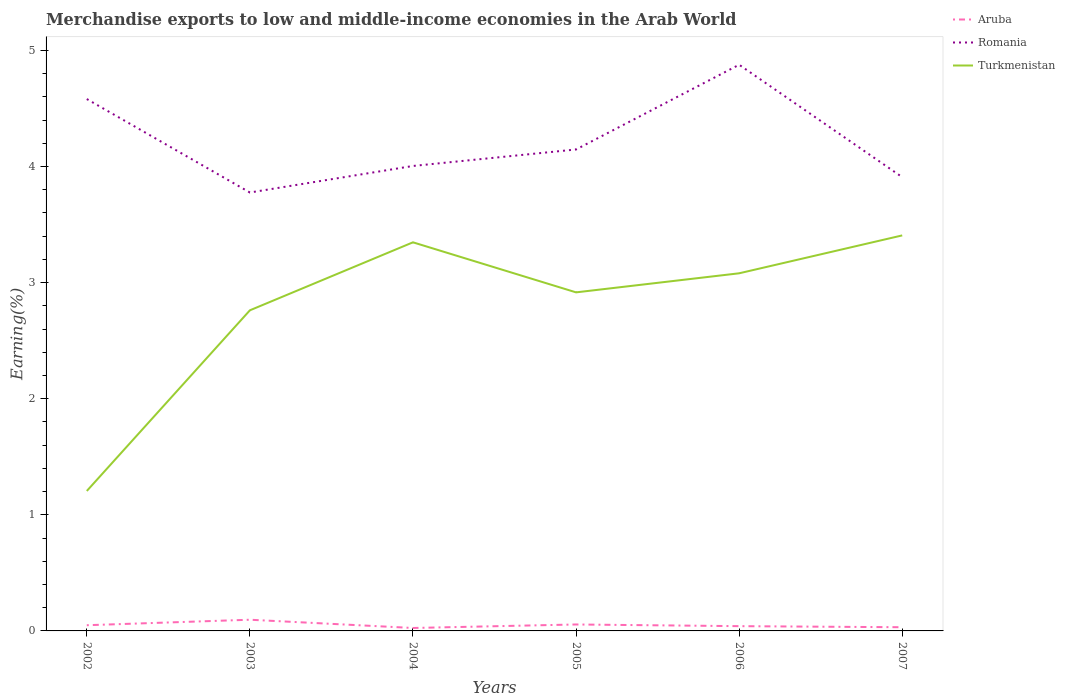How many different coloured lines are there?
Your answer should be very brief. 3. Across all years, what is the maximum percentage of amount earned from merchandise exports in Aruba?
Keep it short and to the point. 0.03. In which year was the percentage of amount earned from merchandise exports in Romania maximum?
Ensure brevity in your answer.  2003. What is the total percentage of amount earned from merchandise exports in Aruba in the graph?
Keep it short and to the point. 0.06. What is the difference between the highest and the second highest percentage of amount earned from merchandise exports in Turkmenistan?
Provide a short and direct response. 2.2. What is the difference between the highest and the lowest percentage of amount earned from merchandise exports in Romania?
Offer a terse response. 2. Is the percentage of amount earned from merchandise exports in Romania strictly greater than the percentage of amount earned from merchandise exports in Aruba over the years?
Make the answer very short. No. How many lines are there?
Provide a succinct answer. 3. Does the graph contain any zero values?
Offer a terse response. No. How many legend labels are there?
Offer a terse response. 3. What is the title of the graph?
Your answer should be compact. Merchandise exports to low and middle-income economies in the Arab World. Does "Caribbean small states" appear as one of the legend labels in the graph?
Offer a very short reply. No. What is the label or title of the X-axis?
Provide a short and direct response. Years. What is the label or title of the Y-axis?
Your response must be concise. Earning(%). What is the Earning(%) in Aruba in 2002?
Offer a very short reply. 0.05. What is the Earning(%) in Romania in 2002?
Your answer should be very brief. 4.58. What is the Earning(%) of Turkmenistan in 2002?
Offer a very short reply. 1.21. What is the Earning(%) in Aruba in 2003?
Your answer should be very brief. 0.1. What is the Earning(%) of Romania in 2003?
Give a very brief answer. 3.78. What is the Earning(%) of Turkmenistan in 2003?
Provide a succinct answer. 2.76. What is the Earning(%) in Aruba in 2004?
Your answer should be compact. 0.03. What is the Earning(%) in Romania in 2004?
Offer a terse response. 4. What is the Earning(%) of Turkmenistan in 2004?
Offer a terse response. 3.35. What is the Earning(%) in Aruba in 2005?
Your response must be concise. 0.06. What is the Earning(%) of Romania in 2005?
Provide a short and direct response. 4.15. What is the Earning(%) of Turkmenistan in 2005?
Your answer should be compact. 2.92. What is the Earning(%) of Aruba in 2006?
Ensure brevity in your answer.  0.04. What is the Earning(%) in Romania in 2006?
Your answer should be very brief. 4.88. What is the Earning(%) of Turkmenistan in 2006?
Provide a short and direct response. 3.08. What is the Earning(%) in Aruba in 2007?
Provide a short and direct response. 0.03. What is the Earning(%) of Romania in 2007?
Provide a short and direct response. 3.91. What is the Earning(%) of Turkmenistan in 2007?
Ensure brevity in your answer.  3.41. Across all years, what is the maximum Earning(%) in Aruba?
Keep it short and to the point. 0.1. Across all years, what is the maximum Earning(%) in Romania?
Give a very brief answer. 4.88. Across all years, what is the maximum Earning(%) in Turkmenistan?
Provide a succinct answer. 3.41. Across all years, what is the minimum Earning(%) in Aruba?
Give a very brief answer. 0.03. Across all years, what is the minimum Earning(%) of Romania?
Give a very brief answer. 3.78. Across all years, what is the minimum Earning(%) in Turkmenistan?
Ensure brevity in your answer.  1.21. What is the total Earning(%) of Aruba in the graph?
Provide a succinct answer. 0.3. What is the total Earning(%) in Romania in the graph?
Offer a very short reply. 25.29. What is the total Earning(%) in Turkmenistan in the graph?
Your answer should be compact. 16.71. What is the difference between the Earning(%) of Aruba in 2002 and that in 2003?
Ensure brevity in your answer.  -0.05. What is the difference between the Earning(%) in Romania in 2002 and that in 2003?
Offer a terse response. 0.8. What is the difference between the Earning(%) in Turkmenistan in 2002 and that in 2003?
Provide a succinct answer. -1.56. What is the difference between the Earning(%) in Aruba in 2002 and that in 2004?
Make the answer very short. 0.02. What is the difference between the Earning(%) in Romania in 2002 and that in 2004?
Your answer should be very brief. 0.58. What is the difference between the Earning(%) in Turkmenistan in 2002 and that in 2004?
Make the answer very short. -2.14. What is the difference between the Earning(%) of Aruba in 2002 and that in 2005?
Keep it short and to the point. -0.01. What is the difference between the Earning(%) of Romania in 2002 and that in 2005?
Offer a very short reply. 0.43. What is the difference between the Earning(%) in Turkmenistan in 2002 and that in 2005?
Your answer should be compact. -1.71. What is the difference between the Earning(%) in Aruba in 2002 and that in 2006?
Provide a short and direct response. 0.01. What is the difference between the Earning(%) in Romania in 2002 and that in 2006?
Provide a short and direct response. -0.3. What is the difference between the Earning(%) in Turkmenistan in 2002 and that in 2006?
Offer a terse response. -1.87. What is the difference between the Earning(%) of Aruba in 2002 and that in 2007?
Offer a very short reply. 0.02. What is the difference between the Earning(%) in Romania in 2002 and that in 2007?
Ensure brevity in your answer.  0.67. What is the difference between the Earning(%) in Turkmenistan in 2002 and that in 2007?
Offer a very short reply. -2.2. What is the difference between the Earning(%) of Aruba in 2003 and that in 2004?
Your answer should be very brief. 0.07. What is the difference between the Earning(%) of Romania in 2003 and that in 2004?
Keep it short and to the point. -0.23. What is the difference between the Earning(%) of Turkmenistan in 2003 and that in 2004?
Provide a succinct answer. -0.59. What is the difference between the Earning(%) in Aruba in 2003 and that in 2005?
Make the answer very short. 0.04. What is the difference between the Earning(%) in Romania in 2003 and that in 2005?
Offer a very short reply. -0.37. What is the difference between the Earning(%) in Turkmenistan in 2003 and that in 2005?
Ensure brevity in your answer.  -0.15. What is the difference between the Earning(%) of Aruba in 2003 and that in 2006?
Offer a very short reply. 0.06. What is the difference between the Earning(%) of Romania in 2003 and that in 2006?
Your answer should be very brief. -1.1. What is the difference between the Earning(%) of Turkmenistan in 2003 and that in 2006?
Your answer should be compact. -0.32. What is the difference between the Earning(%) in Aruba in 2003 and that in 2007?
Keep it short and to the point. 0.06. What is the difference between the Earning(%) of Romania in 2003 and that in 2007?
Ensure brevity in your answer.  -0.13. What is the difference between the Earning(%) in Turkmenistan in 2003 and that in 2007?
Keep it short and to the point. -0.65. What is the difference between the Earning(%) in Aruba in 2004 and that in 2005?
Keep it short and to the point. -0.03. What is the difference between the Earning(%) in Romania in 2004 and that in 2005?
Provide a succinct answer. -0.14. What is the difference between the Earning(%) in Turkmenistan in 2004 and that in 2005?
Provide a short and direct response. 0.43. What is the difference between the Earning(%) in Aruba in 2004 and that in 2006?
Offer a terse response. -0.02. What is the difference between the Earning(%) of Romania in 2004 and that in 2006?
Ensure brevity in your answer.  -0.87. What is the difference between the Earning(%) in Turkmenistan in 2004 and that in 2006?
Keep it short and to the point. 0.27. What is the difference between the Earning(%) of Aruba in 2004 and that in 2007?
Offer a terse response. -0.01. What is the difference between the Earning(%) of Romania in 2004 and that in 2007?
Keep it short and to the point. 0.1. What is the difference between the Earning(%) in Turkmenistan in 2004 and that in 2007?
Provide a succinct answer. -0.06. What is the difference between the Earning(%) of Aruba in 2005 and that in 2006?
Provide a short and direct response. 0.01. What is the difference between the Earning(%) in Romania in 2005 and that in 2006?
Ensure brevity in your answer.  -0.73. What is the difference between the Earning(%) of Turkmenistan in 2005 and that in 2006?
Your response must be concise. -0.16. What is the difference between the Earning(%) in Aruba in 2005 and that in 2007?
Give a very brief answer. 0.02. What is the difference between the Earning(%) in Romania in 2005 and that in 2007?
Provide a short and direct response. 0.24. What is the difference between the Earning(%) of Turkmenistan in 2005 and that in 2007?
Keep it short and to the point. -0.49. What is the difference between the Earning(%) of Aruba in 2006 and that in 2007?
Ensure brevity in your answer.  0.01. What is the difference between the Earning(%) in Romania in 2006 and that in 2007?
Offer a very short reply. 0.97. What is the difference between the Earning(%) in Turkmenistan in 2006 and that in 2007?
Your response must be concise. -0.33. What is the difference between the Earning(%) in Aruba in 2002 and the Earning(%) in Romania in 2003?
Ensure brevity in your answer.  -3.73. What is the difference between the Earning(%) in Aruba in 2002 and the Earning(%) in Turkmenistan in 2003?
Provide a succinct answer. -2.71. What is the difference between the Earning(%) in Romania in 2002 and the Earning(%) in Turkmenistan in 2003?
Offer a terse response. 1.82. What is the difference between the Earning(%) in Aruba in 2002 and the Earning(%) in Romania in 2004?
Make the answer very short. -3.96. What is the difference between the Earning(%) in Aruba in 2002 and the Earning(%) in Turkmenistan in 2004?
Keep it short and to the point. -3.3. What is the difference between the Earning(%) in Romania in 2002 and the Earning(%) in Turkmenistan in 2004?
Ensure brevity in your answer.  1.23. What is the difference between the Earning(%) of Aruba in 2002 and the Earning(%) of Romania in 2005?
Your answer should be very brief. -4.1. What is the difference between the Earning(%) in Aruba in 2002 and the Earning(%) in Turkmenistan in 2005?
Provide a succinct answer. -2.87. What is the difference between the Earning(%) in Romania in 2002 and the Earning(%) in Turkmenistan in 2005?
Make the answer very short. 1.66. What is the difference between the Earning(%) of Aruba in 2002 and the Earning(%) of Romania in 2006?
Provide a succinct answer. -4.83. What is the difference between the Earning(%) in Aruba in 2002 and the Earning(%) in Turkmenistan in 2006?
Your answer should be very brief. -3.03. What is the difference between the Earning(%) of Romania in 2002 and the Earning(%) of Turkmenistan in 2006?
Your answer should be very brief. 1.5. What is the difference between the Earning(%) of Aruba in 2002 and the Earning(%) of Romania in 2007?
Your response must be concise. -3.86. What is the difference between the Earning(%) of Aruba in 2002 and the Earning(%) of Turkmenistan in 2007?
Your answer should be very brief. -3.36. What is the difference between the Earning(%) of Romania in 2002 and the Earning(%) of Turkmenistan in 2007?
Provide a short and direct response. 1.17. What is the difference between the Earning(%) in Aruba in 2003 and the Earning(%) in Romania in 2004?
Your answer should be very brief. -3.91. What is the difference between the Earning(%) in Aruba in 2003 and the Earning(%) in Turkmenistan in 2004?
Your response must be concise. -3.25. What is the difference between the Earning(%) in Romania in 2003 and the Earning(%) in Turkmenistan in 2004?
Provide a succinct answer. 0.43. What is the difference between the Earning(%) in Aruba in 2003 and the Earning(%) in Romania in 2005?
Give a very brief answer. -4.05. What is the difference between the Earning(%) of Aruba in 2003 and the Earning(%) of Turkmenistan in 2005?
Provide a succinct answer. -2.82. What is the difference between the Earning(%) in Romania in 2003 and the Earning(%) in Turkmenistan in 2005?
Offer a terse response. 0.86. What is the difference between the Earning(%) in Aruba in 2003 and the Earning(%) in Romania in 2006?
Offer a terse response. -4.78. What is the difference between the Earning(%) in Aruba in 2003 and the Earning(%) in Turkmenistan in 2006?
Your answer should be very brief. -2.98. What is the difference between the Earning(%) in Romania in 2003 and the Earning(%) in Turkmenistan in 2006?
Ensure brevity in your answer.  0.7. What is the difference between the Earning(%) in Aruba in 2003 and the Earning(%) in Romania in 2007?
Offer a very short reply. -3.81. What is the difference between the Earning(%) of Aruba in 2003 and the Earning(%) of Turkmenistan in 2007?
Your answer should be compact. -3.31. What is the difference between the Earning(%) in Romania in 2003 and the Earning(%) in Turkmenistan in 2007?
Your answer should be very brief. 0.37. What is the difference between the Earning(%) in Aruba in 2004 and the Earning(%) in Romania in 2005?
Offer a terse response. -4.12. What is the difference between the Earning(%) of Aruba in 2004 and the Earning(%) of Turkmenistan in 2005?
Ensure brevity in your answer.  -2.89. What is the difference between the Earning(%) in Romania in 2004 and the Earning(%) in Turkmenistan in 2005?
Make the answer very short. 1.09. What is the difference between the Earning(%) in Aruba in 2004 and the Earning(%) in Romania in 2006?
Give a very brief answer. -4.85. What is the difference between the Earning(%) of Aruba in 2004 and the Earning(%) of Turkmenistan in 2006?
Provide a short and direct response. -3.05. What is the difference between the Earning(%) of Romania in 2004 and the Earning(%) of Turkmenistan in 2006?
Your answer should be compact. 0.92. What is the difference between the Earning(%) in Aruba in 2004 and the Earning(%) in Romania in 2007?
Give a very brief answer. -3.88. What is the difference between the Earning(%) of Aruba in 2004 and the Earning(%) of Turkmenistan in 2007?
Your response must be concise. -3.38. What is the difference between the Earning(%) of Romania in 2004 and the Earning(%) of Turkmenistan in 2007?
Keep it short and to the point. 0.6. What is the difference between the Earning(%) of Aruba in 2005 and the Earning(%) of Romania in 2006?
Provide a succinct answer. -4.82. What is the difference between the Earning(%) in Aruba in 2005 and the Earning(%) in Turkmenistan in 2006?
Your answer should be compact. -3.02. What is the difference between the Earning(%) in Romania in 2005 and the Earning(%) in Turkmenistan in 2006?
Offer a very short reply. 1.07. What is the difference between the Earning(%) in Aruba in 2005 and the Earning(%) in Romania in 2007?
Your answer should be compact. -3.85. What is the difference between the Earning(%) of Aruba in 2005 and the Earning(%) of Turkmenistan in 2007?
Ensure brevity in your answer.  -3.35. What is the difference between the Earning(%) of Romania in 2005 and the Earning(%) of Turkmenistan in 2007?
Provide a succinct answer. 0.74. What is the difference between the Earning(%) of Aruba in 2006 and the Earning(%) of Romania in 2007?
Your answer should be very brief. -3.87. What is the difference between the Earning(%) in Aruba in 2006 and the Earning(%) in Turkmenistan in 2007?
Offer a very short reply. -3.37. What is the difference between the Earning(%) in Romania in 2006 and the Earning(%) in Turkmenistan in 2007?
Your answer should be compact. 1.47. What is the average Earning(%) of Aruba per year?
Your response must be concise. 0.05. What is the average Earning(%) in Romania per year?
Your answer should be very brief. 4.22. What is the average Earning(%) in Turkmenistan per year?
Your response must be concise. 2.79. In the year 2002, what is the difference between the Earning(%) of Aruba and Earning(%) of Romania?
Provide a short and direct response. -4.53. In the year 2002, what is the difference between the Earning(%) of Aruba and Earning(%) of Turkmenistan?
Offer a terse response. -1.16. In the year 2002, what is the difference between the Earning(%) of Romania and Earning(%) of Turkmenistan?
Offer a very short reply. 3.38. In the year 2003, what is the difference between the Earning(%) of Aruba and Earning(%) of Romania?
Make the answer very short. -3.68. In the year 2003, what is the difference between the Earning(%) of Aruba and Earning(%) of Turkmenistan?
Your answer should be very brief. -2.66. In the year 2003, what is the difference between the Earning(%) in Romania and Earning(%) in Turkmenistan?
Ensure brevity in your answer.  1.01. In the year 2004, what is the difference between the Earning(%) of Aruba and Earning(%) of Romania?
Your answer should be compact. -3.98. In the year 2004, what is the difference between the Earning(%) of Aruba and Earning(%) of Turkmenistan?
Keep it short and to the point. -3.32. In the year 2004, what is the difference between the Earning(%) of Romania and Earning(%) of Turkmenistan?
Your response must be concise. 0.66. In the year 2005, what is the difference between the Earning(%) in Aruba and Earning(%) in Romania?
Make the answer very short. -4.09. In the year 2005, what is the difference between the Earning(%) in Aruba and Earning(%) in Turkmenistan?
Offer a terse response. -2.86. In the year 2005, what is the difference between the Earning(%) in Romania and Earning(%) in Turkmenistan?
Your response must be concise. 1.23. In the year 2006, what is the difference between the Earning(%) in Aruba and Earning(%) in Romania?
Keep it short and to the point. -4.83. In the year 2006, what is the difference between the Earning(%) in Aruba and Earning(%) in Turkmenistan?
Provide a short and direct response. -3.04. In the year 2006, what is the difference between the Earning(%) of Romania and Earning(%) of Turkmenistan?
Your answer should be compact. 1.8. In the year 2007, what is the difference between the Earning(%) of Aruba and Earning(%) of Romania?
Make the answer very short. -3.88. In the year 2007, what is the difference between the Earning(%) of Aruba and Earning(%) of Turkmenistan?
Offer a very short reply. -3.37. In the year 2007, what is the difference between the Earning(%) in Romania and Earning(%) in Turkmenistan?
Provide a short and direct response. 0.5. What is the ratio of the Earning(%) in Aruba in 2002 to that in 2003?
Ensure brevity in your answer.  0.51. What is the ratio of the Earning(%) in Romania in 2002 to that in 2003?
Offer a very short reply. 1.21. What is the ratio of the Earning(%) of Turkmenistan in 2002 to that in 2003?
Your answer should be very brief. 0.44. What is the ratio of the Earning(%) of Aruba in 2002 to that in 2004?
Your response must be concise. 1.94. What is the ratio of the Earning(%) of Romania in 2002 to that in 2004?
Provide a succinct answer. 1.14. What is the ratio of the Earning(%) in Turkmenistan in 2002 to that in 2004?
Provide a succinct answer. 0.36. What is the ratio of the Earning(%) in Aruba in 2002 to that in 2005?
Offer a very short reply. 0.88. What is the ratio of the Earning(%) of Romania in 2002 to that in 2005?
Keep it short and to the point. 1.1. What is the ratio of the Earning(%) of Turkmenistan in 2002 to that in 2005?
Offer a very short reply. 0.41. What is the ratio of the Earning(%) of Aruba in 2002 to that in 2006?
Your answer should be compact. 1.2. What is the ratio of the Earning(%) of Romania in 2002 to that in 2006?
Make the answer very short. 0.94. What is the ratio of the Earning(%) of Turkmenistan in 2002 to that in 2006?
Keep it short and to the point. 0.39. What is the ratio of the Earning(%) in Aruba in 2002 to that in 2007?
Your response must be concise. 1.54. What is the ratio of the Earning(%) of Romania in 2002 to that in 2007?
Make the answer very short. 1.17. What is the ratio of the Earning(%) of Turkmenistan in 2002 to that in 2007?
Your answer should be very brief. 0.35. What is the ratio of the Earning(%) in Aruba in 2003 to that in 2004?
Your answer should be compact. 3.81. What is the ratio of the Earning(%) of Romania in 2003 to that in 2004?
Make the answer very short. 0.94. What is the ratio of the Earning(%) of Turkmenistan in 2003 to that in 2004?
Offer a very short reply. 0.82. What is the ratio of the Earning(%) in Aruba in 2003 to that in 2005?
Offer a terse response. 1.74. What is the ratio of the Earning(%) in Romania in 2003 to that in 2005?
Make the answer very short. 0.91. What is the ratio of the Earning(%) of Turkmenistan in 2003 to that in 2005?
Your answer should be compact. 0.95. What is the ratio of the Earning(%) in Aruba in 2003 to that in 2006?
Provide a short and direct response. 2.35. What is the ratio of the Earning(%) in Romania in 2003 to that in 2006?
Your answer should be very brief. 0.77. What is the ratio of the Earning(%) of Turkmenistan in 2003 to that in 2006?
Keep it short and to the point. 0.9. What is the ratio of the Earning(%) in Aruba in 2003 to that in 2007?
Your answer should be very brief. 3.03. What is the ratio of the Earning(%) in Romania in 2003 to that in 2007?
Make the answer very short. 0.97. What is the ratio of the Earning(%) of Turkmenistan in 2003 to that in 2007?
Your response must be concise. 0.81. What is the ratio of the Earning(%) of Aruba in 2004 to that in 2005?
Offer a terse response. 0.46. What is the ratio of the Earning(%) in Romania in 2004 to that in 2005?
Ensure brevity in your answer.  0.97. What is the ratio of the Earning(%) of Turkmenistan in 2004 to that in 2005?
Your answer should be compact. 1.15. What is the ratio of the Earning(%) of Aruba in 2004 to that in 2006?
Offer a very short reply. 0.62. What is the ratio of the Earning(%) in Romania in 2004 to that in 2006?
Provide a short and direct response. 0.82. What is the ratio of the Earning(%) in Turkmenistan in 2004 to that in 2006?
Provide a succinct answer. 1.09. What is the ratio of the Earning(%) of Aruba in 2004 to that in 2007?
Your answer should be compact. 0.79. What is the ratio of the Earning(%) of Romania in 2004 to that in 2007?
Keep it short and to the point. 1.02. What is the ratio of the Earning(%) of Turkmenistan in 2004 to that in 2007?
Offer a terse response. 0.98. What is the ratio of the Earning(%) of Aruba in 2005 to that in 2006?
Offer a terse response. 1.35. What is the ratio of the Earning(%) of Romania in 2005 to that in 2006?
Your response must be concise. 0.85. What is the ratio of the Earning(%) in Turkmenistan in 2005 to that in 2006?
Your answer should be compact. 0.95. What is the ratio of the Earning(%) in Aruba in 2005 to that in 2007?
Keep it short and to the point. 1.75. What is the ratio of the Earning(%) in Romania in 2005 to that in 2007?
Make the answer very short. 1.06. What is the ratio of the Earning(%) in Turkmenistan in 2005 to that in 2007?
Ensure brevity in your answer.  0.86. What is the ratio of the Earning(%) in Aruba in 2006 to that in 2007?
Make the answer very short. 1.29. What is the ratio of the Earning(%) of Romania in 2006 to that in 2007?
Provide a short and direct response. 1.25. What is the ratio of the Earning(%) of Turkmenistan in 2006 to that in 2007?
Offer a terse response. 0.9. What is the difference between the highest and the second highest Earning(%) of Aruba?
Ensure brevity in your answer.  0.04. What is the difference between the highest and the second highest Earning(%) in Romania?
Your answer should be compact. 0.3. What is the difference between the highest and the second highest Earning(%) of Turkmenistan?
Your answer should be compact. 0.06. What is the difference between the highest and the lowest Earning(%) in Aruba?
Offer a terse response. 0.07. What is the difference between the highest and the lowest Earning(%) of Romania?
Your response must be concise. 1.1. What is the difference between the highest and the lowest Earning(%) of Turkmenistan?
Provide a succinct answer. 2.2. 